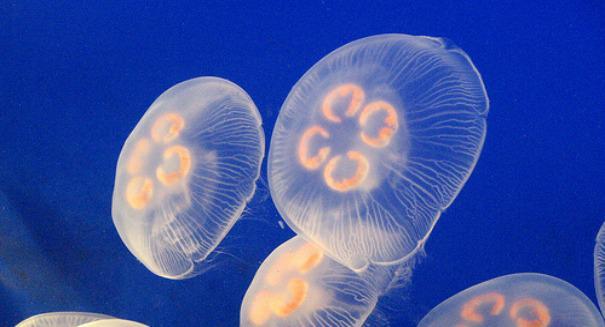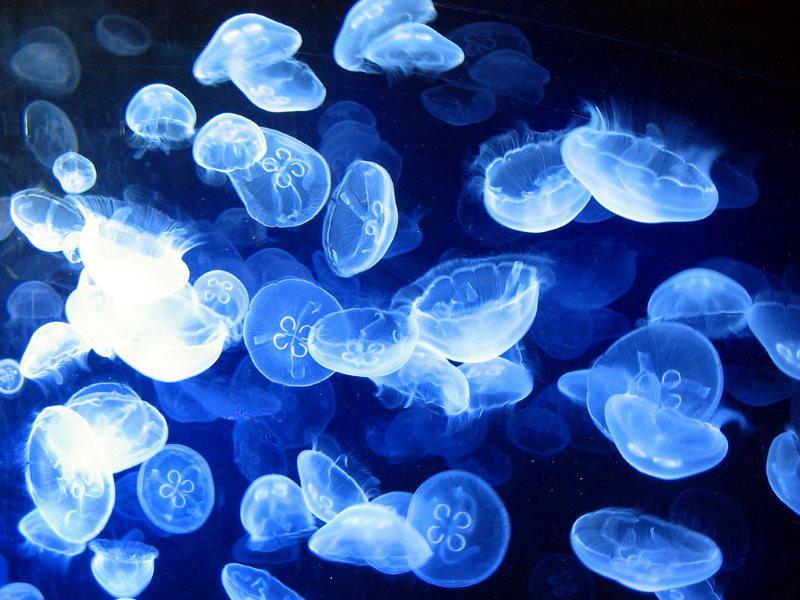The first image is the image on the left, the second image is the image on the right. Evaluate the accuracy of this statement regarding the images: "There are three jellyfish". Is it true? Answer yes or no. No. 